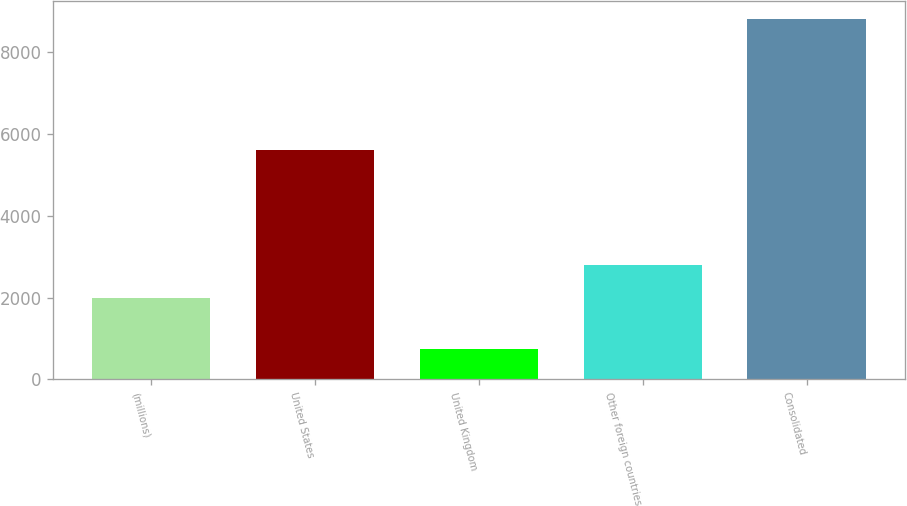<chart> <loc_0><loc_0><loc_500><loc_500><bar_chart><fcel>(millions)<fcel>United States<fcel>United Kingdom<fcel>Other foreign countries<fcel>Consolidated<nl><fcel>2003<fcel>5608.3<fcel>740.2<fcel>2810.13<fcel>8811.5<nl></chart> 